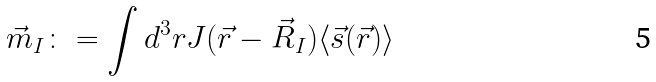Convert formula to latex. <formula><loc_0><loc_0><loc_500><loc_500>\vec { m } _ { I } \colon = \int d ^ { 3 } r J ( \vec { r } - \vec { R } _ { I } ) \langle \vec { s } ( \vec { r } ) \rangle</formula> 